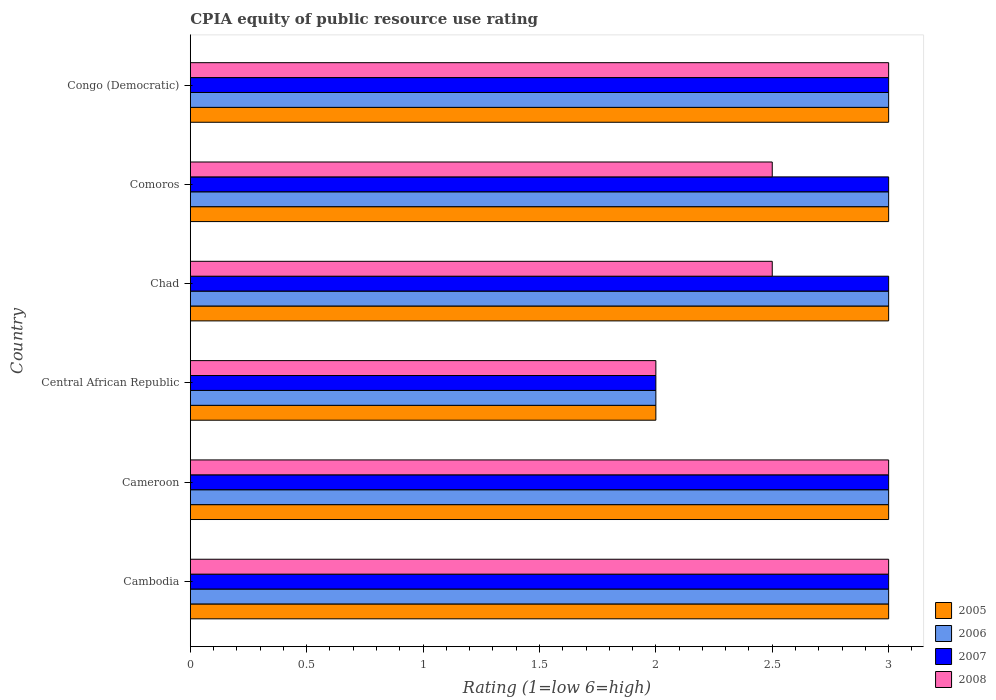How many different coloured bars are there?
Your answer should be very brief. 4. How many groups of bars are there?
Provide a succinct answer. 6. Are the number of bars on each tick of the Y-axis equal?
Keep it short and to the point. Yes. What is the label of the 2nd group of bars from the top?
Your answer should be compact. Comoros. In how many cases, is the number of bars for a given country not equal to the number of legend labels?
Your answer should be very brief. 0. Across all countries, what is the maximum CPIA rating in 2007?
Your response must be concise. 3. In which country was the CPIA rating in 2005 maximum?
Your response must be concise. Cambodia. In which country was the CPIA rating in 2005 minimum?
Keep it short and to the point. Central African Republic. What is the average CPIA rating in 2005 per country?
Make the answer very short. 2.83. What is the difference between the CPIA rating in 2008 and CPIA rating in 2006 in Congo (Democratic)?
Provide a succinct answer. 0. In how many countries, is the CPIA rating in 2008 greater than 1.1 ?
Your answer should be compact. 6. Is the difference between the CPIA rating in 2008 in Cambodia and Congo (Democratic) greater than the difference between the CPIA rating in 2006 in Cambodia and Congo (Democratic)?
Give a very brief answer. No. What is the difference between the highest and the second highest CPIA rating in 2006?
Your answer should be compact. 0. In how many countries, is the CPIA rating in 2006 greater than the average CPIA rating in 2006 taken over all countries?
Your answer should be very brief. 5. Is the sum of the CPIA rating in 2006 in Cambodia and Cameroon greater than the maximum CPIA rating in 2005 across all countries?
Make the answer very short. Yes. Is it the case that in every country, the sum of the CPIA rating in 2007 and CPIA rating in 2006 is greater than the sum of CPIA rating in 2005 and CPIA rating in 2008?
Keep it short and to the point. No. What does the 4th bar from the bottom in Central African Republic represents?
Your response must be concise. 2008. How many bars are there?
Your answer should be compact. 24. Are all the bars in the graph horizontal?
Offer a terse response. Yes. What is the difference between two consecutive major ticks on the X-axis?
Give a very brief answer. 0.5. Does the graph contain any zero values?
Keep it short and to the point. No. Does the graph contain grids?
Your answer should be compact. No. What is the title of the graph?
Make the answer very short. CPIA equity of public resource use rating. What is the label or title of the Y-axis?
Offer a very short reply. Country. What is the Rating (1=low 6=high) in 2005 in Cambodia?
Make the answer very short. 3. What is the Rating (1=low 6=high) of 2006 in Cambodia?
Make the answer very short. 3. What is the Rating (1=low 6=high) in 2008 in Cambodia?
Provide a short and direct response. 3. What is the Rating (1=low 6=high) of 2005 in Cameroon?
Your response must be concise. 3. What is the Rating (1=low 6=high) of 2007 in Cameroon?
Offer a terse response. 3. What is the Rating (1=low 6=high) of 2008 in Cameroon?
Offer a very short reply. 3. What is the Rating (1=low 6=high) in 2007 in Central African Republic?
Ensure brevity in your answer.  2. What is the Rating (1=low 6=high) of 2008 in Chad?
Keep it short and to the point. 2.5. What is the Rating (1=low 6=high) in 2007 in Comoros?
Ensure brevity in your answer.  3. What is the Rating (1=low 6=high) in 2008 in Comoros?
Provide a succinct answer. 2.5. What is the Rating (1=low 6=high) in 2006 in Congo (Democratic)?
Your answer should be compact. 3. What is the Rating (1=low 6=high) in 2007 in Congo (Democratic)?
Your answer should be compact. 3. Across all countries, what is the maximum Rating (1=low 6=high) of 2005?
Provide a succinct answer. 3. Across all countries, what is the maximum Rating (1=low 6=high) of 2006?
Offer a terse response. 3. Across all countries, what is the minimum Rating (1=low 6=high) of 2005?
Your answer should be compact. 2. What is the difference between the Rating (1=low 6=high) of 2005 in Cambodia and that in Cameroon?
Make the answer very short. 0. What is the difference between the Rating (1=low 6=high) of 2007 in Cambodia and that in Cameroon?
Your answer should be very brief. 0. What is the difference between the Rating (1=low 6=high) of 2005 in Cambodia and that in Central African Republic?
Make the answer very short. 1. What is the difference between the Rating (1=low 6=high) in 2008 in Cambodia and that in Central African Republic?
Ensure brevity in your answer.  1. What is the difference between the Rating (1=low 6=high) in 2005 in Cambodia and that in Chad?
Keep it short and to the point. 0. What is the difference between the Rating (1=low 6=high) of 2006 in Cambodia and that in Chad?
Make the answer very short. 0. What is the difference between the Rating (1=low 6=high) of 2007 in Cambodia and that in Comoros?
Your response must be concise. 0. What is the difference between the Rating (1=low 6=high) of 2007 in Cameroon and that in Comoros?
Keep it short and to the point. 0. What is the difference between the Rating (1=low 6=high) of 2008 in Cameroon and that in Comoros?
Offer a terse response. 0.5. What is the difference between the Rating (1=low 6=high) of 2006 in Central African Republic and that in Chad?
Offer a terse response. -1. What is the difference between the Rating (1=low 6=high) of 2007 in Central African Republic and that in Chad?
Offer a very short reply. -1. What is the difference between the Rating (1=low 6=high) in 2005 in Central African Republic and that in Comoros?
Keep it short and to the point. -1. What is the difference between the Rating (1=low 6=high) in 2006 in Central African Republic and that in Comoros?
Ensure brevity in your answer.  -1. What is the difference between the Rating (1=low 6=high) of 2006 in Central African Republic and that in Congo (Democratic)?
Make the answer very short. -1. What is the difference between the Rating (1=low 6=high) of 2007 in Central African Republic and that in Congo (Democratic)?
Give a very brief answer. -1. What is the difference between the Rating (1=low 6=high) of 2006 in Chad and that in Comoros?
Your answer should be very brief. 0. What is the difference between the Rating (1=low 6=high) in 2005 in Chad and that in Congo (Democratic)?
Make the answer very short. 0. What is the difference between the Rating (1=low 6=high) in 2006 in Chad and that in Congo (Democratic)?
Your answer should be very brief. 0. What is the difference between the Rating (1=low 6=high) of 2005 in Comoros and that in Congo (Democratic)?
Ensure brevity in your answer.  0. What is the difference between the Rating (1=low 6=high) of 2005 in Cambodia and the Rating (1=low 6=high) of 2006 in Cameroon?
Provide a short and direct response. 0. What is the difference between the Rating (1=low 6=high) in 2005 in Cambodia and the Rating (1=low 6=high) in 2008 in Cameroon?
Provide a short and direct response. 0. What is the difference between the Rating (1=low 6=high) in 2006 in Cambodia and the Rating (1=low 6=high) in 2007 in Cameroon?
Keep it short and to the point. 0. What is the difference between the Rating (1=low 6=high) in 2005 in Cambodia and the Rating (1=low 6=high) in 2007 in Central African Republic?
Your answer should be very brief. 1. What is the difference between the Rating (1=low 6=high) of 2005 in Cambodia and the Rating (1=low 6=high) of 2008 in Central African Republic?
Provide a succinct answer. 1. What is the difference between the Rating (1=low 6=high) in 2006 in Cambodia and the Rating (1=low 6=high) in 2007 in Central African Republic?
Offer a terse response. 1. What is the difference between the Rating (1=low 6=high) in 2005 in Cambodia and the Rating (1=low 6=high) in 2007 in Chad?
Give a very brief answer. 0. What is the difference between the Rating (1=low 6=high) of 2005 in Cambodia and the Rating (1=low 6=high) of 2008 in Chad?
Make the answer very short. 0.5. What is the difference between the Rating (1=low 6=high) of 2006 in Cambodia and the Rating (1=low 6=high) of 2007 in Chad?
Your answer should be compact. 0. What is the difference between the Rating (1=low 6=high) in 2006 in Cambodia and the Rating (1=low 6=high) in 2008 in Chad?
Provide a short and direct response. 0.5. What is the difference between the Rating (1=low 6=high) in 2007 in Cambodia and the Rating (1=low 6=high) in 2008 in Chad?
Your response must be concise. 0.5. What is the difference between the Rating (1=low 6=high) in 2005 in Cambodia and the Rating (1=low 6=high) in 2006 in Comoros?
Offer a terse response. 0. What is the difference between the Rating (1=low 6=high) of 2005 in Cambodia and the Rating (1=low 6=high) of 2007 in Comoros?
Make the answer very short. 0. What is the difference between the Rating (1=low 6=high) in 2005 in Cambodia and the Rating (1=low 6=high) in 2008 in Comoros?
Give a very brief answer. 0.5. What is the difference between the Rating (1=low 6=high) in 2007 in Cambodia and the Rating (1=low 6=high) in 2008 in Comoros?
Your response must be concise. 0.5. What is the difference between the Rating (1=low 6=high) in 2005 in Cambodia and the Rating (1=low 6=high) in 2006 in Congo (Democratic)?
Your answer should be compact. 0. What is the difference between the Rating (1=low 6=high) of 2005 in Cambodia and the Rating (1=low 6=high) of 2007 in Congo (Democratic)?
Offer a terse response. 0. What is the difference between the Rating (1=low 6=high) in 2005 in Cambodia and the Rating (1=low 6=high) in 2008 in Congo (Democratic)?
Your answer should be very brief. 0. What is the difference between the Rating (1=low 6=high) of 2006 in Cambodia and the Rating (1=low 6=high) of 2007 in Congo (Democratic)?
Provide a short and direct response. 0. What is the difference between the Rating (1=low 6=high) of 2006 in Cambodia and the Rating (1=low 6=high) of 2008 in Congo (Democratic)?
Ensure brevity in your answer.  0. What is the difference between the Rating (1=low 6=high) in 2007 in Cambodia and the Rating (1=low 6=high) in 2008 in Congo (Democratic)?
Provide a short and direct response. 0. What is the difference between the Rating (1=low 6=high) in 2005 in Cameroon and the Rating (1=low 6=high) in 2007 in Central African Republic?
Offer a very short reply. 1. What is the difference between the Rating (1=low 6=high) of 2005 in Cameroon and the Rating (1=low 6=high) of 2008 in Central African Republic?
Offer a terse response. 1. What is the difference between the Rating (1=low 6=high) in 2006 in Cameroon and the Rating (1=low 6=high) in 2007 in Central African Republic?
Provide a short and direct response. 1. What is the difference between the Rating (1=low 6=high) of 2006 in Cameroon and the Rating (1=low 6=high) of 2008 in Central African Republic?
Make the answer very short. 1. What is the difference between the Rating (1=low 6=high) of 2007 in Cameroon and the Rating (1=low 6=high) of 2008 in Central African Republic?
Offer a very short reply. 1. What is the difference between the Rating (1=low 6=high) in 2005 in Cameroon and the Rating (1=low 6=high) in 2007 in Chad?
Give a very brief answer. 0. What is the difference between the Rating (1=low 6=high) in 2005 in Cameroon and the Rating (1=low 6=high) in 2008 in Chad?
Ensure brevity in your answer.  0.5. What is the difference between the Rating (1=low 6=high) in 2007 in Cameroon and the Rating (1=low 6=high) in 2008 in Chad?
Keep it short and to the point. 0.5. What is the difference between the Rating (1=low 6=high) of 2005 in Cameroon and the Rating (1=low 6=high) of 2006 in Comoros?
Offer a terse response. 0. What is the difference between the Rating (1=low 6=high) of 2006 in Cameroon and the Rating (1=low 6=high) of 2007 in Comoros?
Your response must be concise. 0. What is the difference between the Rating (1=low 6=high) of 2006 in Cameroon and the Rating (1=low 6=high) of 2008 in Comoros?
Make the answer very short. 0.5. What is the difference between the Rating (1=low 6=high) of 2007 in Cameroon and the Rating (1=low 6=high) of 2008 in Congo (Democratic)?
Provide a short and direct response. 0. What is the difference between the Rating (1=low 6=high) of 2005 in Central African Republic and the Rating (1=low 6=high) of 2007 in Chad?
Provide a succinct answer. -1. What is the difference between the Rating (1=low 6=high) in 2005 in Central African Republic and the Rating (1=low 6=high) in 2008 in Chad?
Provide a succinct answer. -0.5. What is the difference between the Rating (1=low 6=high) of 2006 in Central African Republic and the Rating (1=low 6=high) of 2007 in Chad?
Ensure brevity in your answer.  -1. What is the difference between the Rating (1=low 6=high) in 2005 in Central African Republic and the Rating (1=low 6=high) in 2008 in Comoros?
Your answer should be compact. -0.5. What is the difference between the Rating (1=low 6=high) of 2007 in Central African Republic and the Rating (1=low 6=high) of 2008 in Comoros?
Your answer should be very brief. -0.5. What is the difference between the Rating (1=low 6=high) of 2005 in Central African Republic and the Rating (1=low 6=high) of 2008 in Congo (Democratic)?
Ensure brevity in your answer.  -1. What is the difference between the Rating (1=low 6=high) in 2006 in Central African Republic and the Rating (1=low 6=high) in 2007 in Congo (Democratic)?
Provide a succinct answer. -1. What is the difference between the Rating (1=low 6=high) of 2005 in Chad and the Rating (1=low 6=high) of 2006 in Comoros?
Your answer should be compact. 0. What is the difference between the Rating (1=low 6=high) of 2005 in Chad and the Rating (1=low 6=high) of 2007 in Comoros?
Make the answer very short. 0. What is the difference between the Rating (1=low 6=high) in 2006 in Chad and the Rating (1=low 6=high) in 2008 in Comoros?
Keep it short and to the point. 0.5. What is the difference between the Rating (1=low 6=high) of 2005 in Chad and the Rating (1=low 6=high) of 2008 in Congo (Democratic)?
Make the answer very short. 0. What is the difference between the Rating (1=low 6=high) in 2006 in Chad and the Rating (1=low 6=high) in 2008 in Congo (Democratic)?
Provide a short and direct response. 0. What is the difference between the Rating (1=low 6=high) of 2007 in Chad and the Rating (1=low 6=high) of 2008 in Congo (Democratic)?
Provide a succinct answer. 0. What is the difference between the Rating (1=low 6=high) in 2005 in Comoros and the Rating (1=low 6=high) in 2006 in Congo (Democratic)?
Your response must be concise. 0. What is the difference between the Rating (1=low 6=high) in 2005 in Comoros and the Rating (1=low 6=high) in 2007 in Congo (Democratic)?
Offer a terse response. 0. What is the difference between the Rating (1=low 6=high) of 2005 in Comoros and the Rating (1=low 6=high) of 2008 in Congo (Democratic)?
Ensure brevity in your answer.  0. What is the difference between the Rating (1=low 6=high) of 2006 in Comoros and the Rating (1=low 6=high) of 2007 in Congo (Democratic)?
Your answer should be compact. 0. What is the difference between the Rating (1=low 6=high) of 2007 in Comoros and the Rating (1=low 6=high) of 2008 in Congo (Democratic)?
Your answer should be compact. 0. What is the average Rating (1=low 6=high) of 2005 per country?
Your response must be concise. 2.83. What is the average Rating (1=low 6=high) in 2006 per country?
Offer a terse response. 2.83. What is the average Rating (1=low 6=high) in 2007 per country?
Your response must be concise. 2.83. What is the average Rating (1=low 6=high) of 2008 per country?
Your answer should be compact. 2.67. What is the difference between the Rating (1=low 6=high) in 2005 and Rating (1=low 6=high) in 2007 in Cambodia?
Ensure brevity in your answer.  0. What is the difference between the Rating (1=low 6=high) in 2006 and Rating (1=low 6=high) in 2007 in Cambodia?
Make the answer very short. 0. What is the difference between the Rating (1=low 6=high) of 2006 and Rating (1=low 6=high) of 2008 in Cambodia?
Keep it short and to the point. 0. What is the difference between the Rating (1=low 6=high) in 2007 and Rating (1=low 6=high) in 2008 in Cambodia?
Provide a short and direct response. 0. What is the difference between the Rating (1=low 6=high) of 2005 and Rating (1=low 6=high) of 2006 in Cameroon?
Offer a terse response. 0. What is the difference between the Rating (1=low 6=high) in 2006 and Rating (1=low 6=high) in 2007 in Cameroon?
Offer a very short reply. 0. What is the difference between the Rating (1=low 6=high) of 2006 and Rating (1=low 6=high) of 2008 in Cameroon?
Your response must be concise. 0. What is the difference between the Rating (1=low 6=high) of 2007 and Rating (1=low 6=high) of 2008 in Cameroon?
Your answer should be very brief. 0. What is the difference between the Rating (1=low 6=high) of 2005 and Rating (1=low 6=high) of 2006 in Central African Republic?
Keep it short and to the point. 0. What is the difference between the Rating (1=low 6=high) of 2006 and Rating (1=low 6=high) of 2007 in Central African Republic?
Ensure brevity in your answer.  0. What is the difference between the Rating (1=low 6=high) in 2006 and Rating (1=low 6=high) in 2008 in Central African Republic?
Provide a short and direct response. 0. What is the difference between the Rating (1=low 6=high) in 2007 and Rating (1=low 6=high) in 2008 in Central African Republic?
Keep it short and to the point. 0. What is the difference between the Rating (1=low 6=high) in 2005 and Rating (1=low 6=high) in 2007 in Chad?
Your response must be concise. 0. What is the difference between the Rating (1=low 6=high) of 2005 and Rating (1=low 6=high) of 2006 in Comoros?
Make the answer very short. 0. What is the difference between the Rating (1=low 6=high) of 2006 and Rating (1=low 6=high) of 2007 in Comoros?
Make the answer very short. 0. What is the difference between the Rating (1=low 6=high) in 2006 and Rating (1=low 6=high) in 2008 in Congo (Democratic)?
Provide a succinct answer. 0. What is the difference between the Rating (1=low 6=high) of 2007 and Rating (1=low 6=high) of 2008 in Congo (Democratic)?
Keep it short and to the point. 0. What is the ratio of the Rating (1=low 6=high) in 2005 in Cambodia to that in Cameroon?
Provide a short and direct response. 1. What is the ratio of the Rating (1=low 6=high) in 2006 in Cambodia to that in Cameroon?
Provide a short and direct response. 1. What is the ratio of the Rating (1=low 6=high) in 2007 in Cambodia to that in Cameroon?
Your response must be concise. 1. What is the ratio of the Rating (1=low 6=high) of 2005 in Cambodia to that in Central African Republic?
Provide a short and direct response. 1.5. What is the ratio of the Rating (1=low 6=high) of 2007 in Cambodia to that in Central African Republic?
Provide a succinct answer. 1.5. What is the ratio of the Rating (1=low 6=high) in 2005 in Cambodia to that in Chad?
Ensure brevity in your answer.  1. What is the ratio of the Rating (1=low 6=high) in 2007 in Cambodia to that in Chad?
Provide a short and direct response. 1. What is the ratio of the Rating (1=low 6=high) in 2005 in Cambodia to that in Comoros?
Your answer should be compact. 1. What is the ratio of the Rating (1=low 6=high) of 2006 in Cambodia to that in Comoros?
Your response must be concise. 1. What is the ratio of the Rating (1=low 6=high) of 2007 in Cambodia to that in Comoros?
Provide a succinct answer. 1. What is the ratio of the Rating (1=low 6=high) of 2005 in Cambodia to that in Congo (Democratic)?
Make the answer very short. 1. What is the ratio of the Rating (1=low 6=high) of 2007 in Cambodia to that in Congo (Democratic)?
Your answer should be compact. 1. What is the ratio of the Rating (1=low 6=high) of 2008 in Cambodia to that in Congo (Democratic)?
Provide a succinct answer. 1. What is the ratio of the Rating (1=low 6=high) of 2005 in Cameroon to that in Central African Republic?
Your answer should be compact. 1.5. What is the ratio of the Rating (1=low 6=high) of 2007 in Cameroon to that in Central African Republic?
Your answer should be compact. 1.5. What is the ratio of the Rating (1=low 6=high) of 2008 in Cameroon to that in Central African Republic?
Your answer should be very brief. 1.5. What is the ratio of the Rating (1=low 6=high) in 2006 in Cameroon to that in Chad?
Offer a terse response. 1. What is the ratio of the Rating (1=low 6=high) of 2007 in Cameroon to that in Chad?
Offer a terse response. 1. What is the ratio of the Rating (1=low 6=high) of 2008 in Cameroon to that in Chad?
Give a very brief answer. 1.2. What is the ratio of the Rating (1=low 6=high) of 2006 in Cameroon to that in Comoros?
Offer a terse response. 1. What is the ratio of the Rating (1=low 6=high) in 2008 in Cameroon to that in Comoros?
Your response must be concise. 1.2. What is the ratio of the Rating (1=low 6=high) of 2006 in Cameroon to that in Congo (Democratic)?
Your answer should be very brief. 1. What is the ratio of the Rating (1=low 6=high) in 2007 in Cameroon to that in Congo (Democratic)?
Offer a very short reply. 1. What is the ratio of the Rating (1=low 6=high) in 2005 in Central African Republic to that in Chad?
Offer a very short reply. 0.67. What is the ratio of the Rating (1=low 6=high) in 2006 in Central African Republic to that in Chad?
Your answer should be compact. 0.67. What is the ratio of the Rating (1=low 6=high) in 2006 in Central African Republic to that in Comoros?
Give a very brief answer. 0.67. What is the ratio of the Rating (1=low 6=high) of 2008 in Central African Republic to that in Comoros?
Ensure brevity in your answer.  0.8. What is the ratio of the Rating (1=low 6=high) of 2005 in Central African Republic to that in Congo (Democratic)?
Your answer should be very brief. 0.67. What is the ratio of the Rating (1=low 6=high) of 2007 in Central African Republic to that in Congo (Democratic)?
Keep it short and to the point. 0.67. What is the ratio of the Rating (1=low 6=high) in 2005 in Chad to that in Congo (Democratic)?
Provide a short and direct response. 1. What is the ratio of the Rating (1=low 6=high) of 2006 in Chad to that in Congo (Democratic)?
Your response must be concise. 1. What is the ratio of the Rating (1=low 6=high) in 2008 in Chad to that in Congo (Democratic)?
Your response must be concise. 0.83. What is the ratio of the Rating (1=low 6=high) in 2006 in Comoros to that in Congo (Democratic)?
Offer a very short reply. 1. What is the ratio of the Rating (1=low 6=high) in 2008 in Comoros to that in Congo (Democratic)?
Provide a short and direct response. 0.83. What is the difference between the highest and the second highest Rating (1=low 6=high) in 2006?
Make the answer very short. 0. What is the difference between the highest and the second highest Rating (1=low 6=high) of 2008?
Ensure brevity in your answer.  0. What is the difference between the highest and the lowest Rating (1=low 6=high) of 2005?
Provide a succinct answer. 1. What is the difference between the highest and the lowest Rating (1=low 6=high) in 2008?
Your answer should be very brief. 1. 